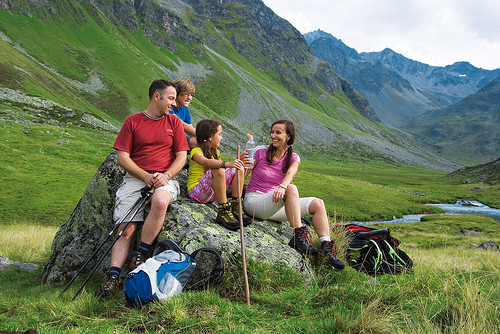<image>
Is the girl on the rock? Yes. Looking at the image, I can see the girl is positioned on top of the rock, with the rock providing support. Is there a man on the rock? Yes. Looking at the image, I can see the man is positioned on top of the rock, with the rock providing support. Is there a bag next to the rock? Yes. The bag is positioned adjacent to the rock, located nearby in the same general area. 